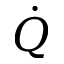<formula> <loc_0><loc_0><loc_500><loc_500>\dot { Q }</formula> 